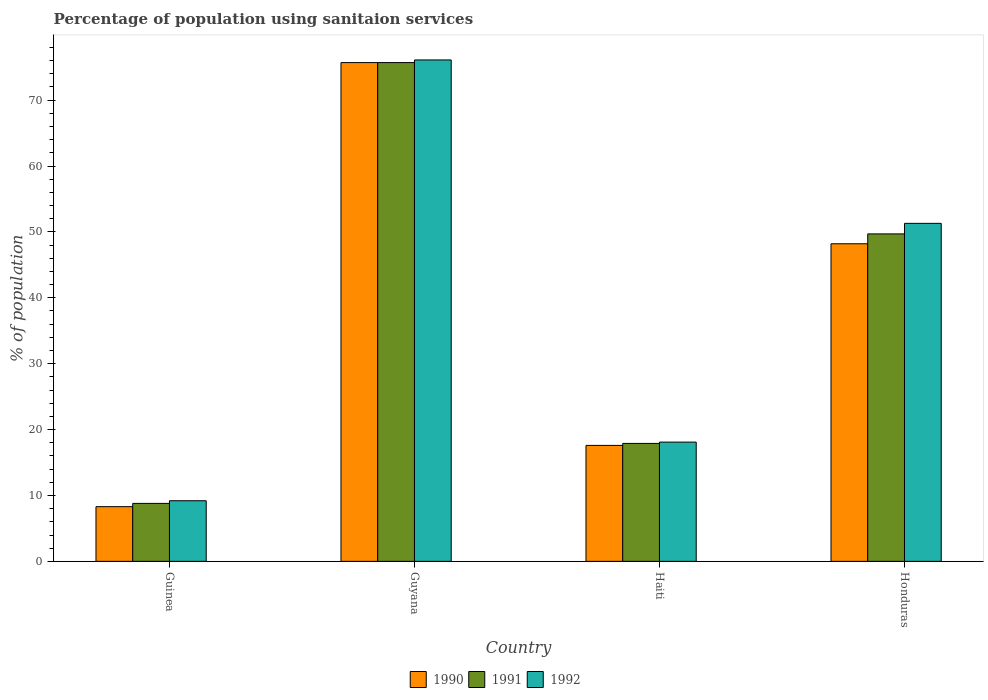How many groups of bars are there?
Give a very brief answer. 4. Are the number of bars on each tick of the X-axis equal?
Provide a succinct answer. Yes. What is the label of the 3rd group of bars from the left?
Offer a very short reply. Haiti. In how many cases, is the number of bars for a given country not equal to the number of legend labels?
Your response must be concise. 0. What is the percentage of population using sanitaion services in 1991 in Guyana?
Offer a very short reply. 75.7. Across all countries, what is the maximum percentage of population using sanitaion services in 1991?
Provide a short and direct response. 75.7. Across all countries, what is the minimum percentage of population using sanitaion services in 1991?
Offer a terse response. 8.8. In which country was the percentage of population using sanitaion services in 1990 maximum?
Provide a short and direct response. Guyana. In which country was the percentage of population using sanitaion services in 1990 minimum?
Offer a terse response. Guinea. What is the total percentage of population using sanitaion services in 1992 in the graph?
Give a very brief answer. 154.7. What is the difference between the percentage of population using sanitaion services in 1991 in Guinea and that in Honduras?
Your answer should be very brief. -40.9. What is the difference between the percentage of population using sanitaion services in 1991 in Honduras and the percentage of population using sanitaion services in 1992 in Guyana?
Offer a very short reply. -26.4. What is the average percentage of population using sanitaion services in 1992 per country?
Make the answer very short. 38.67. What is the difference between the percentage of population using sanitaion services of/in 1990 and percentage of population using sanitaion services of/in 1991 in Guyana?
Keep it short and to the point. 0. What is the ratio of the percentage of population using sanitaion services in 1991 in Guinea to that in Honduras?
Keep it short and to the point. 0.18. Is the percentage of population using sanitaion services in 1991 in Guinea less than that in Haiti?
Ensure brevity in your answer.  Yes. Is the difference between the percentage of population using sanitaion services in 1990 in Guinea and Honduras greater than the difference between the percentage of population using sanitaion services in 1991 in Guinea and Honduras?
Your response must be concise. Yes. What is the difference between the highest and the lowest percentage of population using sanitaion services in 1992?
Keep it short and to the point. 66.9. What does the 1st bar from the left in Haiti represents?
Offer a terse response. 1990. How many bars are there?
Make the answer very short. 12. Are all the bars in the graph horizontal?
Your response must be concise. No. How many countries are there in the graph?
Provide a short and direct response. 4. Are the values on the major ticks of Y-axis written in scientific E-notation?
Provide a succinct answer. No. Does the graph contain grids?
Your answer should be very brief. No. How many legend labels are there?
Make the answer very short. 3. How are the legend labels stacked?
Offer a very short reply. Horizontal. What is the title of the graph?
Offer a terse response. Percentage of population using sanitaion services. Does "1972" appear as one of the legend labels in the graph?
Ensure brevity in your answer.  No. What is the label or title of the X-axis?
Your answer should be very brief. Country. What is the label or title of the Y-axis?
Make the answer very short. % of population. What is the % of population of 1991 in Guinea?
Ensure brevity in your answer.  8.8. What is the % of population of 1992 in Guinea?
Make the answer very short. 9.2. What is the % of population in 1990 in Guyana?
Your answer should be compact. 75.7. What is the % of population in 1991 in Guyana?
Your answer should be very brief. 75.7. What is the % of population in 1992 in Guyana?
Make the answer very short. 76.1. What is the % of population in 1991 in Haiti?
Provide a succinct answer. 17.9. What is the % of population of 1992 in Haiti?
Your answer should be very brief. 18.1. What is the % of population of 1990 in Honduras?
Ensure brevity in your answer.  48.2. What is the % of population in 1991 in Honduras?
Offer a very short reply. 49.7. What is the % of population of 1992 in Honduras?
Offer a terse response. 51.3. Across all countries, what is the maximum % of population of 1990?
Keep it short and to the point. 75.7. Across all countries, what is the maximum % of population in 1991?
Ensure brevity in your answer.  75.7. Across all countries, what is the maximum % of population in 1992?
Offer a terse response. 76.1. Across all countries, what is the minimum % of population in 1990?
Your answer should be compact. 8.3. What is the total % of population of 1990 in the graph?
Keep it short and to the point. 149.8. What is the total % of population of 1991 in the graph?
Provide a succinct answer. 152.1. What is the total % of population in 1992 in the graph?
Keep it short and to the point. 154.7. What is the difference between the % of population in 1990 in Guinea and that in Guyana?
Your answer should be very brief. -67.4. What is the difference between the % of population of 1991 in Guinea and that in Guyana?
Offer a very short reply. -66.9. What is the difference between the % of population of 1992 in Guinea and that in Guyana?
Ensure brevity in your answer.  -66.9. What is the difference between the % of population in 1991 in Guinea and that in Haiti?
Keep it short and to the point. -9.1. What is the difference between the % of population in 1992 in Guinea and that in Haiti?
Keep it short and to the point. -8.9. What is the difference between the % of population in 1990 in Guinea and that in Honduras?
Offer a very short reply. -39.9. What is the difference between the % of population in 1991 in Guinea and that in Honduras?
Give a very brief answer. -40.9. What is the difference between the % of population of 1992 in Guinea and that in Honduras?
Provide a succinct answer. -42.1. What is the difference between the % of population of 1990 in Guyana and that in Haiti?
Offer a very short reply. 58.1. What is the difference between the % of population of 1991 in Guyana and that in Haiti?
Ensure brevity in your answer.  57.8. What is the difference between the % of population of 1990 in Guyana and that in Honduras?
Your response must be concise. 27.5. What is the difference between the % of population in 1991 in Guyana and that in Honduras?
Ensure brevity in your answer.  26. What is the difference between the % of population of 1992 in Guyana and that in Honduras?
Keep it short and to the point. 24.8. What is the difference between the % of population of 1990 in Haiti and that in Honduras?
Your answer should be compact. -30.6. What is the difference between the % of population in 1991 in Haiti and that in Honduras?
Your answer should be very brief. -31.8. What is the difference between the % of population in 1992 in Haiti and that in Honduras?
Offer a very short reply. -33.2. What is the difference between the % of population in 1990 in Guinea and the % of population in 1991 in Guyana?
Your answer should be very brief. -67.4. What is the difference between the % of population in 1990 in Guinea and the % of population in 1992 in Guyana?
Keep it short and to the point. -67.8. What is the difference between the % of population in 1991 in Guinea and the % of population in 1992 in Guyana?
Ensure brevity in your answer.  -67.3. What is the difference between the % of population in 1990 in Guinea and the % of population in 1991 in Haiti?
Give a very brief answer. -9.6. What is the difference between the % of population in 1990 in Guinea and the % of population in 1992 in Haiti?
Make the answer very short. -9.8. What is the difference between the % of population in 1990 in Guinea and the % of population in 1991 in Honduras?
Ensure brevity in your answer.  -41.4. What is the difference between the % of population of 1990 in Guinea and the % of population of 1992 in Honduras?
Your answer should be compact. -43. What is the difference between the % of population in 1991 in Guinea and the % of population in 1992 in Honduras?
Provide a short and direct response. -42.5. What is the difference between the % of population in 1990 in Guyana and the % of population in 1991 in Haiti?
Offer a very short reply. 57.8. What is the difference between the % of population of 1990 in Guyana and the % of population of 1992 in Haiti?
Give a very brief answer. 57.6. What is the difference between the % of population of 1991 in Guyana and the % of population of 1992 in Haiti?
Offer a very short reply. 57.6. What is the difference between the % of population in 1990 in Guyana and the % of population in 1992 in Honduras?
Give a very brief answer. 24.4. What is the difference between the % of population of 1991 in Guyana and the % of population of 1992 in Honduras?
Give a very brief answer. 24.4. What is the difference between the % of population of 1990 in Haiti and the % of population of 1991 in Honduras?
Your response must be concise. -32.1. What is the difference between the % of population of 1990 in Haiti and the % of population of 1992 in Honduras?
Your answer should be very brief. -33.7. What is the difference between the % of population in 1991 in Haiti and the % of population in 1992 in Honduras?
Your answer should be very brief. -33.4. What is the average % of population of 1990 per country?
Your response must be concise. 37.45. What is the average % of population in 1991 per country?
Keep it short and to the point. 38.02. What is the average % of population of 1992 per country?
Your response must be concise. 38.67. What is the difference between the % of population in 1990 and % of population in 1991 in Guinea?
Offer a terse response. -0.5. What is the difference between the % of population of 1990 and % of population of 1991 in Guyana?
Your answer should be compact. 0. What is the difference between the % of population of 1991 and % of population of 1992 in Haiti?
Your answer should be compact. -0.2. What is the difference between the % of population in 1991 and % of population in 1992 in Honduras?
Your response must be concise. -1.6. What is the ratio of the % of population of 1990 in Guinea to that in Guyana?
Keep it short and to the point. 0.11. What is the ratio of the % of population in 1991 in Guinea to that in Guyana?
Offer a terse response. 0.12. What is the ratio of the % of population in 1992 in Guinea to that in Guyana?
Ensure brevity in your answer.  0.12. What is the ratio of the % of population of 1990 in Guinea to that in Haiti?
Provide a short and direct response. 0.47. What is the ratio of the % of population in 1991 in Guinea to that in Haiti?
Your answer should be very brief. 0.49. What is the ratio of the % of population in 1992 in Guinea to that in Haiti?
Provide a succinct answer. 0.51. What is the ratio of the % of population of 1990 in Guinea to that in Honduras?
Your response must be concise. 0.17. What is the ratio of the % of population in 1991 in Guinea to that in Honduras?
Provide a succinct answer. 0.18. What is the ratio of the % of population in 1992 in Guinea to that in Honduras?
Your answer should be very brief. 0.18. What is the ratio of the % of population of 1990 in Guyana to that in Haiti?
Provide a short and direct response. 4.3. What is the ratio of the % of population of 1991 in Guyana to that in Haiti?
Provide a succinct answer. 4.23. What is the ratio of the % of population of 1992 in Guyana to that in Haiti?
Your answer should be very brief. 4.2. What is the ratio of the % of population of 1990 in Guyana to that in Honduras?
Offer a very short reply. 1.57. What is the ratio of the % of population of 1991 in Guyana to that in Honduras?
Give a very brief answer. 1.52. What is the ratio of the % of population of 1992 in Guyana to that in Honduras?
Offer a terse response. 1.48. What is the ratio of the % of population in 1990 in Haiti to that in Honduras?
Give a very brief answer. 0.37. What is the ratio of the % of population of 1991 in Haiti to that in Honduras?
Your answer should be compact. 0.36. What is the ratio of the % of population of 1992 in Haiti to that in Honduras?
Your answer should be very brief. 0.35. What is the difference between the highest and the second highest % of population of 1990?
Offer a very short reply. 27.5. What is the difference between the highest and the second highest % of population in 1991?
Your response must be concise. 26. What is the difference between the highest and the second highest % of population of 1992?
Keep it short and to the point. 24.8. What is the difference between the highest and the lowest % of population of 1990?
Your answer should be very brief. 67.4. What is the difference between the highest and the lowest % of population of 1991?
Make the answer very short. 66.9. What is the difference between the highest and the lowest % of population of 1992?
Your answer should be very brief. 66.9. 